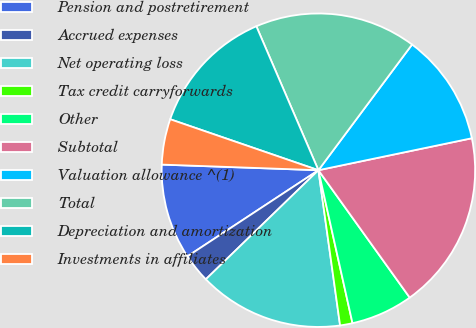Convert chart to OTSL. <chart><loc_0><loc_0><loc_500><loc_500><pie_chart><fcel>Pension and postretirement<fcel>Accrued expenses<fcel>Net operating loss<fcel>Tax credit carryforwards<fcel>Other<fcel>Subtotal<fcel>Valuation allowance ^(1)<fcel>Total<fcel>Depreciation and amortization<fcel>Investments in affiliates<nl><fcel>9.83%<fcel>2.99%<fcel>14.96%<fcel>1.28%<fcel>6.41%<fcel>18.37%<fcel>11.54%<fcel>16.67%<fcel>13.25%<fcel>4.7%<nl></chart> 